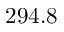Convert formula to latex. <formula><loc_0><loc_0><loc_500><loc_500>2 9 4 . 8</formula> 